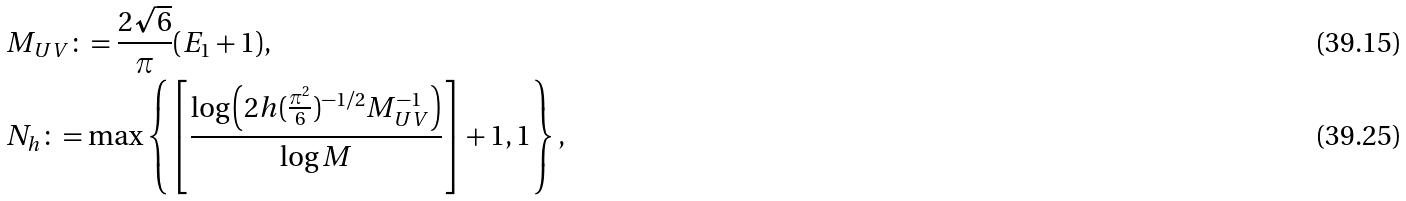Convert formula to latex. <formula><loc_0><loc_0><loc_500><loc_500>& M _ { U V } \colon = \frac { 2 \sqrt { 6 } } { \pi } ( E _ { 1 } + 1 ) , \\ & N _ { h } \colon = \max \left \{ \left [ \frac { \log \left ( 2 h ( \frac { \pi ^ { 2 } } { 6 } ) ^ { - 1 / 2 } M _ { U V } ^ { - 1 } \right ) } { \log M } \right ] + 1 , 1 \right \} ,</formula> 